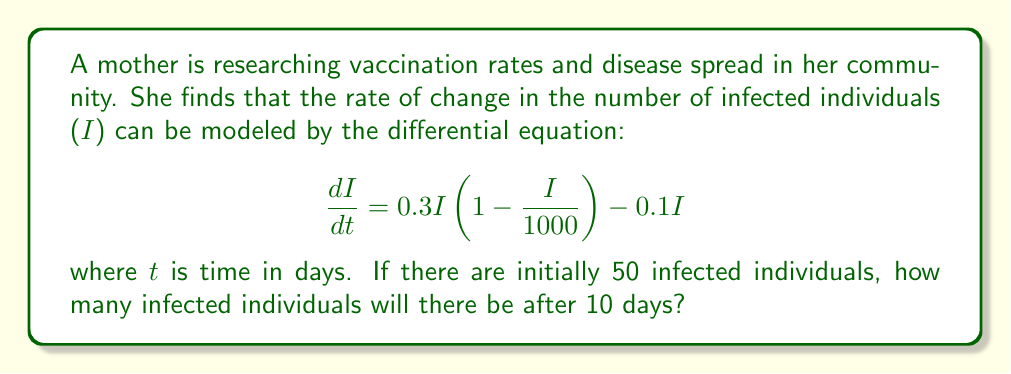What is the answer to this math problem? To solve this problem, we'll use the Runge-Kutta 4th order method (RK4) to approximate the solution to the differential equation.

1) First, let's define our function $f(t,I)$:
   $$f(t,I) = 0.3I(1 - \frac{I}{1000}) - 0.1I = 0.3I - 0.0003I^2 - 0.1I = 0.2I - 0.0003I^2$$

2) We'll use a step size of $h = 1$ day, and iterate 10 times.

3) The RK4 method is defined as:
   $$I_{n+1} = I_n + \frac{1}{6}(k_1 + 2k_2 + 2k_3 + k_4)$$
   where:
   $$k_1 = hf(t_n, I_n)$$
   $$k_2 = hf(t_n + \frac{h}{2}, I_n + \frac{k_1}{2})$$
   $$k_3 = hf(t_n + \frac{h}{2}, I_n + \frac{k_2}{2})$$
   $$k_4 = hf(t_n + h, I_n + k_3)$$

4) Let's calculate for the first day:
   $I_0 = 50$
   $k_1 = 1 \cdot f(0, 50) = 1 \cdot (0.2 \cdot 50 - 0.0003 \cdot 50^2) = 9.25$
   $k_2 = 1 \cdot f(0.5, 50 + 9.25/2) = 1 \cdot (0.2 \cdot 54.625 - 0.0003 \cdot 54.625^2) = 10.0178$
   $k_3 = 1 \cdot f(0.5, 50 + 10.0178/2) = 1 \cdot (0.2 \cdot 55.0089 - 0.0003 \cdot 55.0089^2) = 10.0825$
   $k_4 = 1 \cdot f(1, 50 + 10.0825) = 1 \cdot (0.2 \cdot 60.0825 - 0.0003 \cdot 60.0825^2) = 10.8743$

   $I_1 = 50 + \frac{1}{6}(9.25 + 2(10.0178) + 2(10.0825) + 10.8743) = 60.0475$

5) We repeat this process for the remaining 9 days. The results are:
   Day 2: 71.8452
   Day 3: 85.4947
   Day 4: 101.0959
   Day 5: 118.6449
   Day 6: 138.0305
   Day 7: 159.0396
   Day 8: 181.3665
   Day 9: 204.6225
   Day 10: 228.3520

Therefore, after 10 days, there will be approximately 228 infected individuals.
Answer: 228 infected individuals 